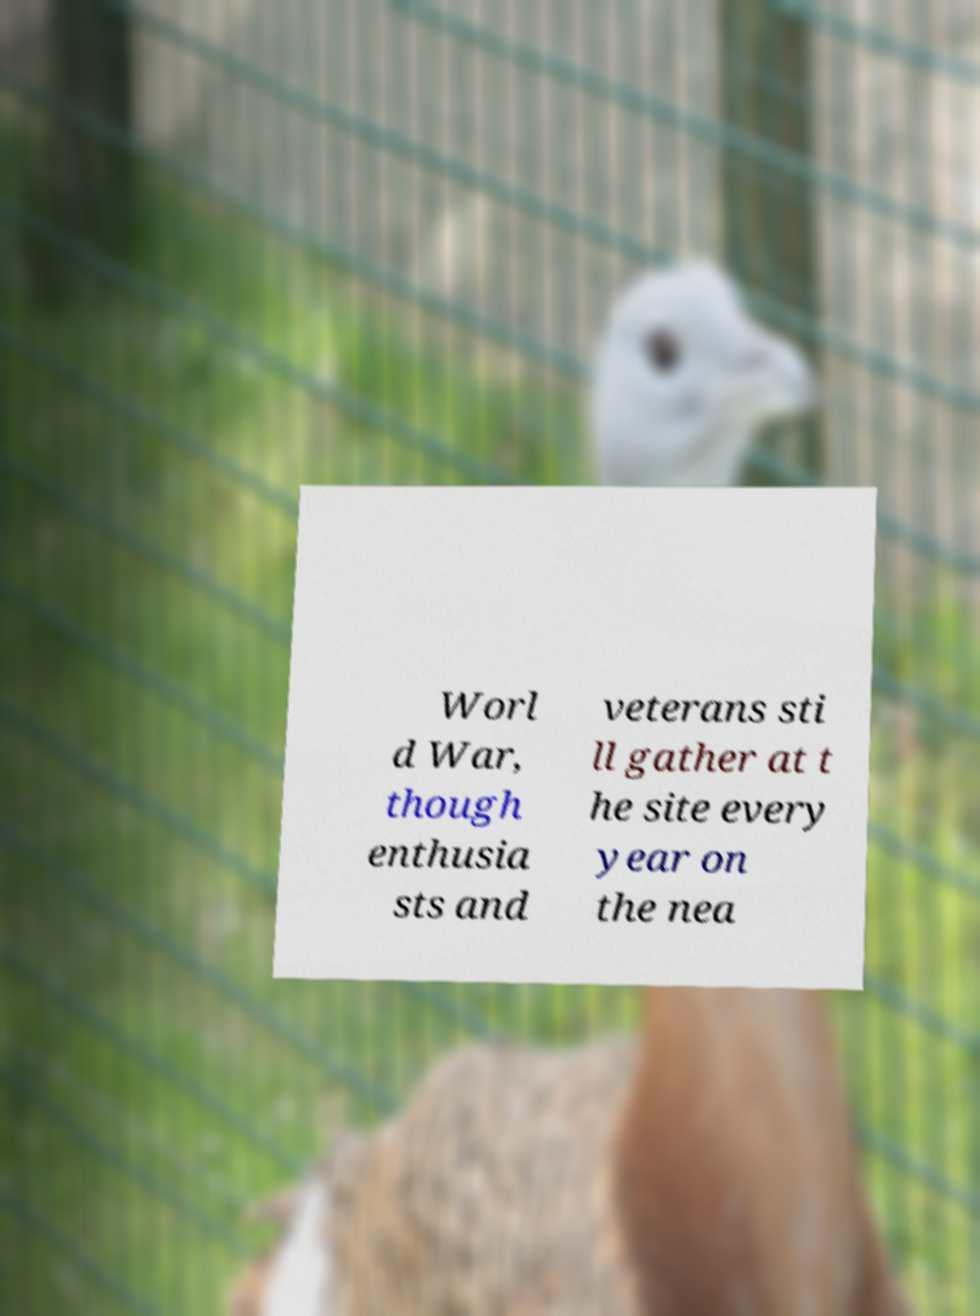Can you accurately transcribe the text from the provided image for me? Worl d War, though enthusia sts and veterans sti ll gather at t he site every year on the nea 